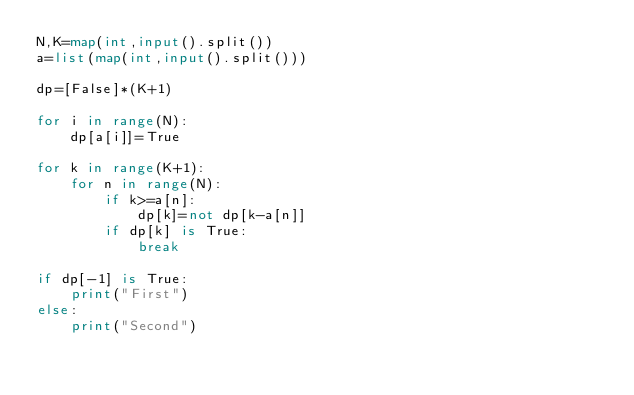Convert code to text. <code><loc_0><loc_0><loc_500><loc_500><_Python_>N,K=map(int,input().split())
a=list(map(int,input().split()))

dp=[False]*(K+1)

for i in range(N):
    dp[a[i]]=True

for k in range(K+1):
    for n in range(N):
        if k>=a[n]:
            dp[k]=not dp[k-a[n]]
        if dp[k] is True:
            break

if dp[-1] is True:
    print("First")
else:
    print("Second")</code> 